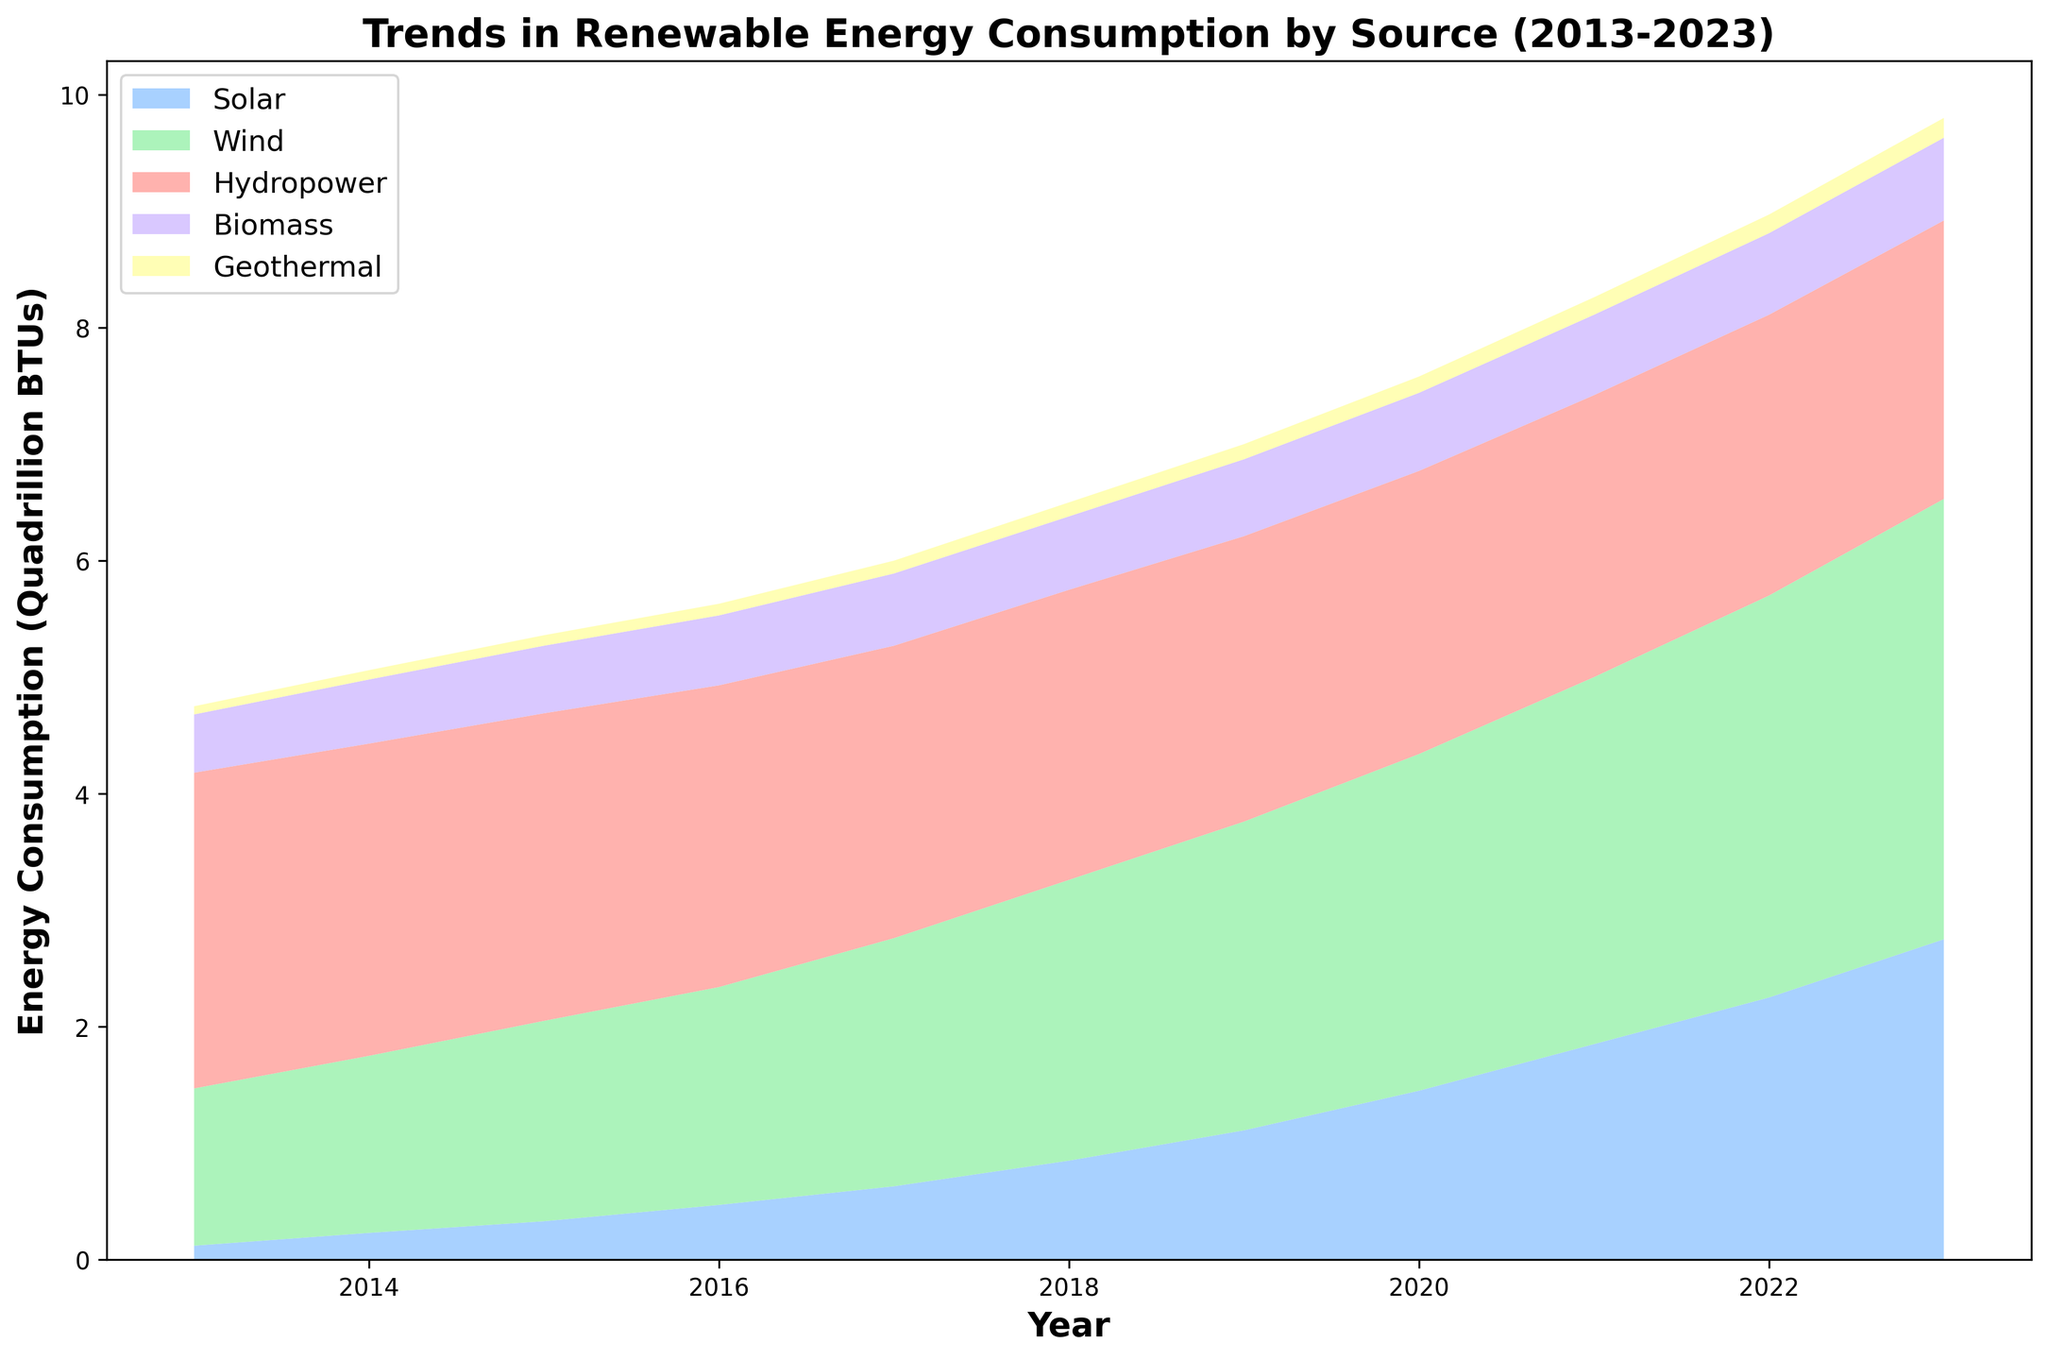Which renewable energy source showed the most significant increase from 2013 to 2023? First, observe the endpoints for each energy source in the span of 2013 to 2023. Solar energy increased from 0.12 to 2.75, Wind from 1.35 to 3.78, Hydropower from 2.71 to 2.39, Biomass from 0.50 to 0.71, and Geothermal from 0.07 to 0.17. Solar has the most significant increase (2.75 - 0.12 = 2.63 quadrillion BTUs).
Answer: Solar Between Wind and Hydropower, which source had a higher consumption in 2023? Look at the values for Wind and Hydropower in 2023. Wind has 3.78, whereas Hydropower has 2.39 quadrillion BTUs. Wind is significantly higher in 2023 compared to Hydropower.
Answer: Wind During which year did Wind energy consumption surpass Hydropower? Track the points where the Wind line crosses above the Hydropower line. Starting in 2017, the Wind consumption value of 2.13 surpasses the Hydropower value of 2.51. Hence, Wind surpassed Hydropower in 2017.
Answer: 2017 Calculate the total energy consumption from Biomass in the first five years (2013-2017)? Sum the Biomass values for the years 2013 to 2017: 0.50 + 0.55 + 0.58 + 0.60 + 0.62 = 2.85 quadrillion BTUs.
Answer: 2.85 Which energy source remained relatively constant over the decade? Review the trends for all sources. Hydropower values stay between 2.39 to 2.71, showing the least variation over the decade.
Answer: Hydropower What is the average annual increase in Solar energy consumption from 2013 to 2023? Calculate the increase: Final value (2.75) - Initial value (0.12) = 2.63. Divide this by the number of years (2023-2013=10): 2.63 / 10 = 0.263 quadrillion BTUs per year.
Answer: 0.263 When did Geothermal energy consumption first reach 0.15 quadrillion BTUs? Find the first year when Geothermal hits or exceeds 0.15. It first reaches 0.15 in 2021.
Answer: 2021 Which year shows the largest annual increase in Solar energy consumption? Calculate the differences between consecutive years for Solar: (2014-2013=0.11, 2015-2014=0.10, 2016-2015=0.14, 2017-2016=0.16, 2018-2017=0.22, 2019-2018=0.26, 2020-2019=0.34, 2021-2020=0.40, 2022-2021=0.40, 2023-2022=0.50). The largest increase is from 2022 to 2023.
Answer: 2023 Compare the total consumption of Geothermal and Biomass over the decade. Which one is higher? Sum the values for both over the years:
Geothermal: 0.07 + 0.08 + 0.09 + 0.10 + 0.11 + 0.12 + 0.13 + 0.14 + 0.15 + 0.16 + 0.17 = 1.32.
Biomass: 0.50 + 0.55 + 0.58 + 0.60 + 0.62 + 0.63 + 0.66 + 0.67 + 0.69 + 0.70 + 0.71 = 6.91.
Thus, Biomass has higher total consumption.
Answer: Biomass What was the trend in Wind energy consumption from 2013 to 2023? Examine the Wind values over the years. They increase steadily from 1.35 to 3.78 quadrillion BTUs. Therefore, the trend is a steady increase.
Answer: Steady increase 